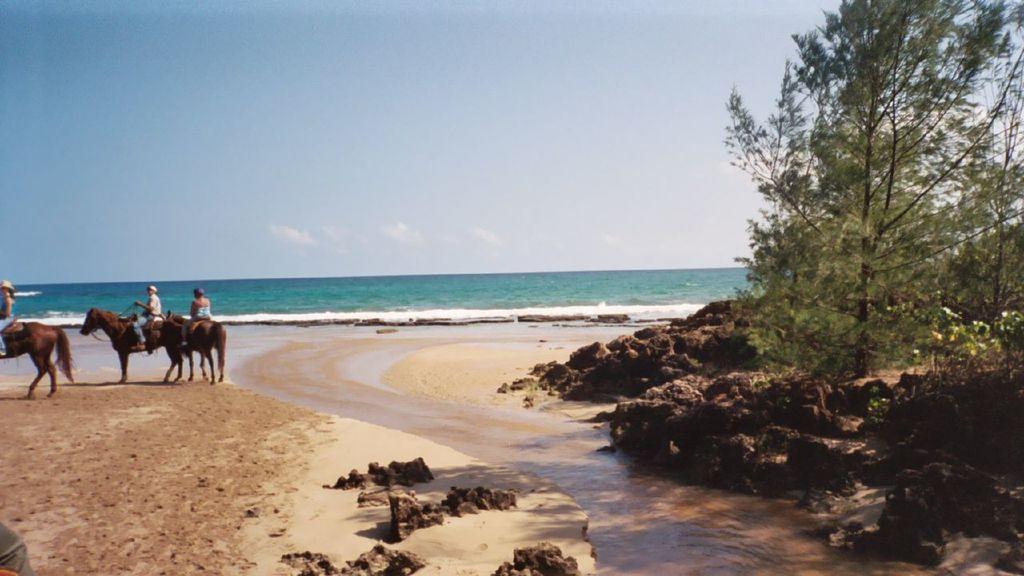Can you describe this image briefly? In this image, I can see three people sitting on the horses. It looks like a seashore. These are the rocks. I think this is a sea. Here is the sky. On the right side of the image, I can see the trees. 